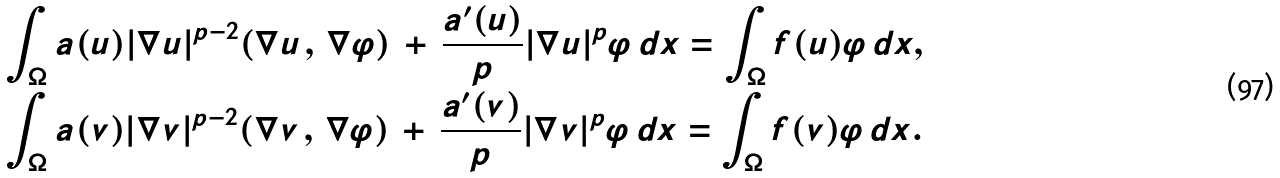Convert formula to latex. <formula><loc_0><loc_0><loc_500><loc_500>& \int _ { \Omega } a ( u ) | \nabla u | ^ { p - 2 } ( \nabla u \, , \, \nabla \varphi ) \, + \, \frac { a ^ { \prime } ( u ) } { p } | \nabla u | ^ { p } \varphi \, d x = \int _ { \Omega } f ( u ) \varphi \, d x , \\ & \int _ { \Omega } a ( v ) | \nabla v | ^ { p - 2 } ( \nabla v \, , \, \nabla \varphi ) \, + \, \frac { a ^ { \prime } ( v ) } { p } | \nabla v | ^ { p } \varphi \, d x = \int _ { \Omega } f ( v ) \varphi \, d x .</formula> 